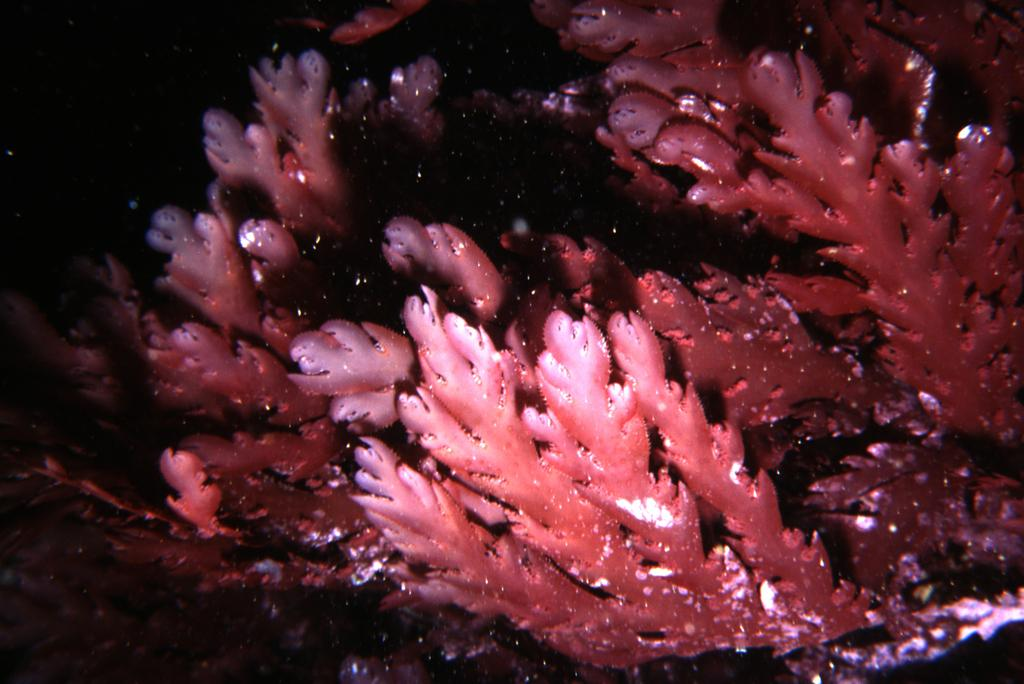What is the setting of the image? The picture is taken underwater. What type of vegetation can be seen in the image? There are water plants in the image. How would you describe the lighting on the left side of the image? The left side of the image appears dark. How many chairs are visible in the image? There are no chairs present in the image, as it is taken underwater and not in a typical setting where chairs would be found. 